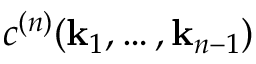<formula> <loc_0><loc_0><loc_500><loc_500>c ^ { ( n ) } ( k _ { 1 } , \dots , k _ { n - 1 } )</formula> 